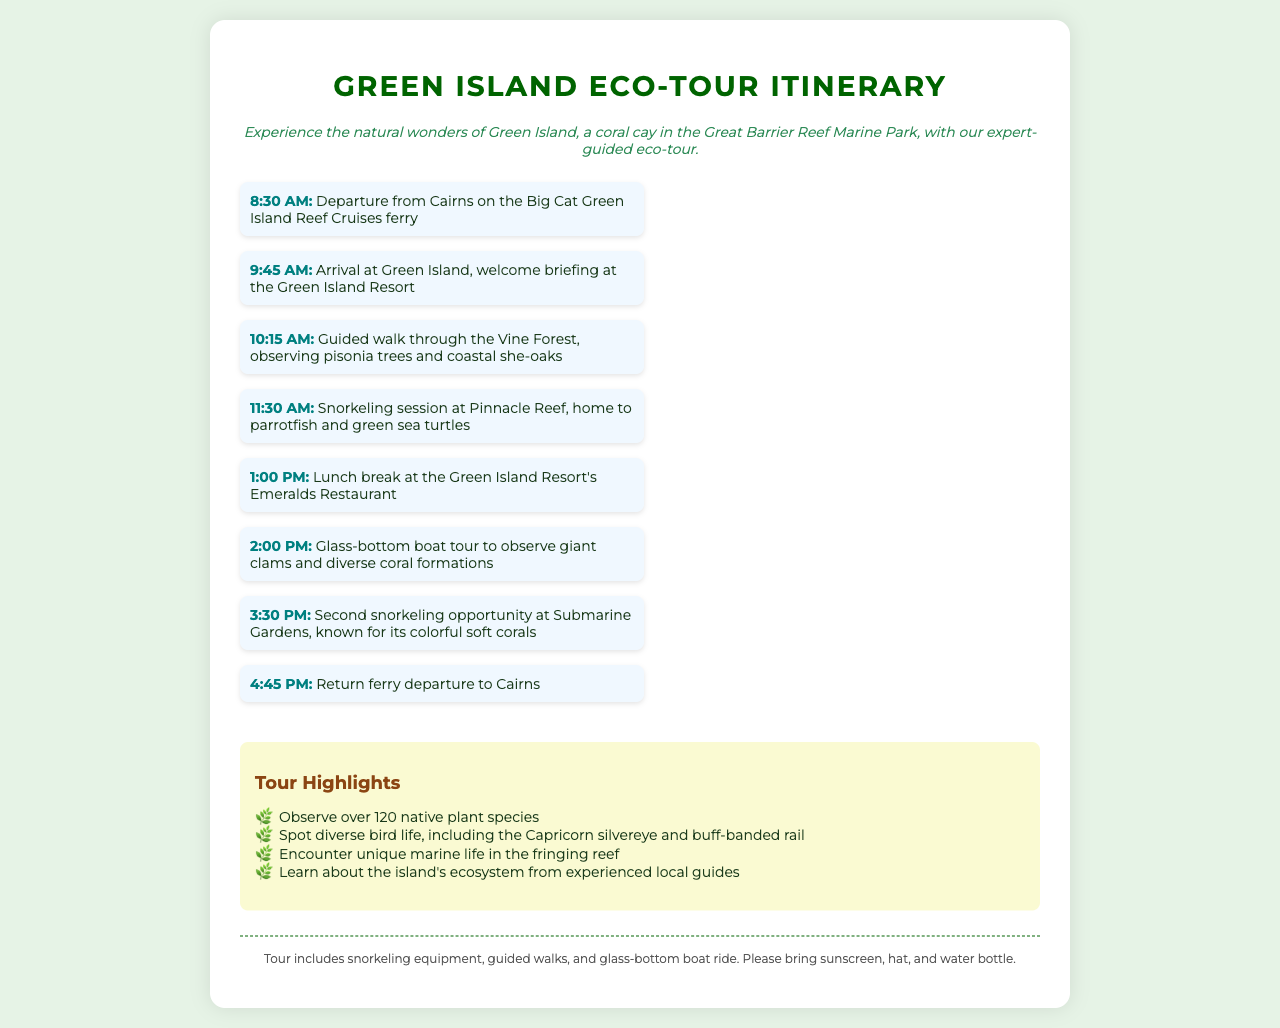What time does the tour start? The tour starts at 8:30 AM with the departure from Cairns on the Big Cat Green Island Reef Cruises ferry.
Answer: 8:30 AM What is included in the tour? The document states that the tour includes snorkeling equipment, guided walks, and a glass-bottom boat ride.
Answer: Snorkeling equipment, guided walks, glass-bottom boat ride Where is the second snorkeling location? The second snorkeling opportunity is at Submarine Gardens, known for its colorful soft corals.
Answer: Submarine Gardens What is the time for lunch? According to the document, lunch is scheduled for 1:00 PM.
Answer: 1:00 PM Which native bird is mentioned in the highlights? The Capricorn silvereye is one of the native birds mentioned in the tour highlights.
Answer: Capricorn silvereye How long does the guided walk last? The guided walk through the Vine Forest starts at 10:15 AM and lasts until 11:30 AM, totaling 1 hour and 15 minutes.
Answer: 1 hour and 15 minutes What restaurant serves lunch? The lunch break takes place at the Green Island Resort's Emeralds Restaurant.
Answer: Emeralds Restaurant What are the first two activities in the itinerary? The first two activities include the welcome briefing at the Green Island Resort and a guided walk through the Vine Forest.
Answer: Welcome briefing and guided walk through the Vine Forest 